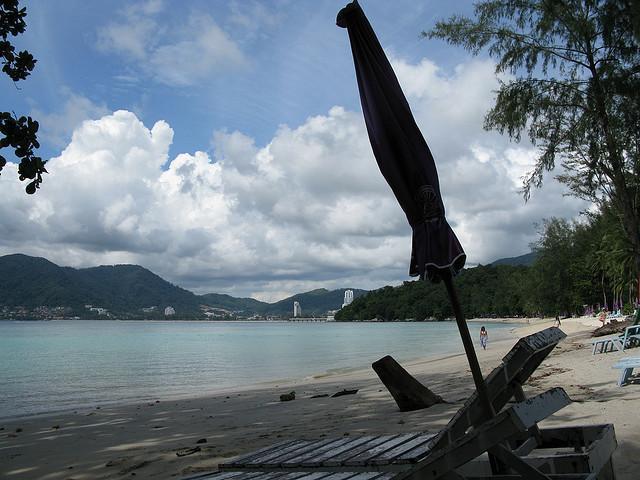How many chairs can be seen?
Give a very brief answer. 2. 